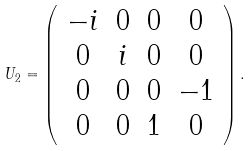Convert formula to latex. <formula><loc_0><loc_0><loc_500><loc_500>U _ { 2 } = \left ( \begin{array} { c c c c } - i & 0 & 0 & 0 \\ 0 & i & 0 & 0 \\ 0 & 0 & 0 & - 1 \\ 0 & 0 & 1 & 0 \end{array} \right ) .</formula> 